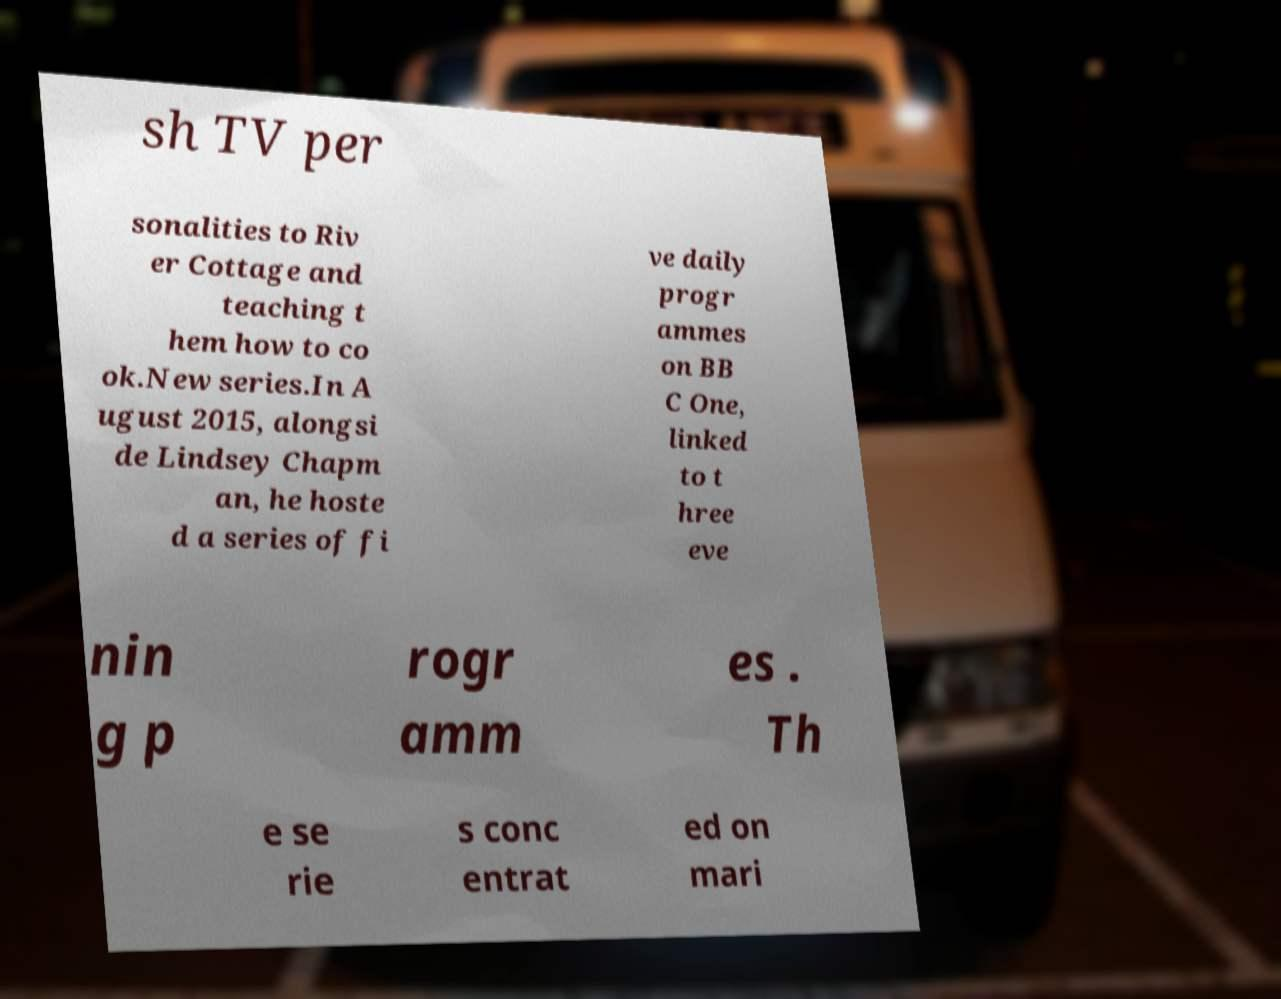Could you assist in decoding the text presented in this image and type it out clearly? sh TV per sonalities to Riv er Cottage and teaching t hem how to co ok.New series.In A ugust 2015, alongsi de Lindsey Chapm an, he hoste d a series of fi ve daily progr ammes on BB C One, linked to t hree eve nin g p rogr amm es . Th e se rie s conc entrat ed on mari 